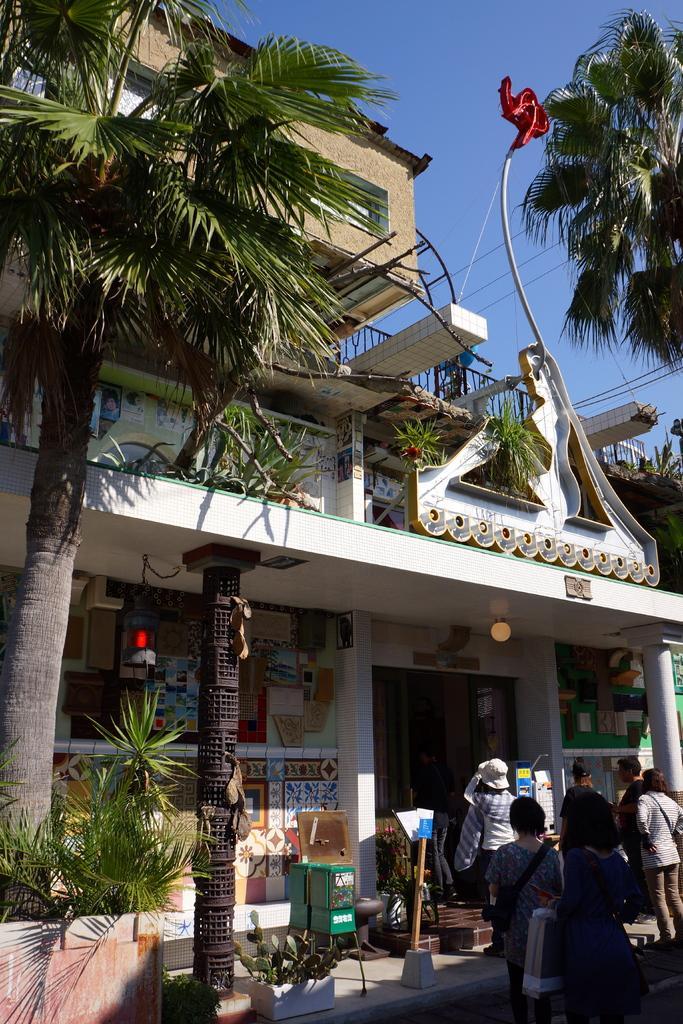Could you give a brief overview of what you see in this image? In this image we can see a building. There are few cables in the image. There are few trees in the image. There are many plants in the image. We can see many people in the image. There is a light in the image. There are few boards in the image. We can see the sky in the image. 